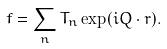Convert formula to latex. <formula><loc_0><loc_0><loc_500><loc_500>f = \sum _ { n } T _ { n } \exp ( i Q \cdot r ) .</formula> 